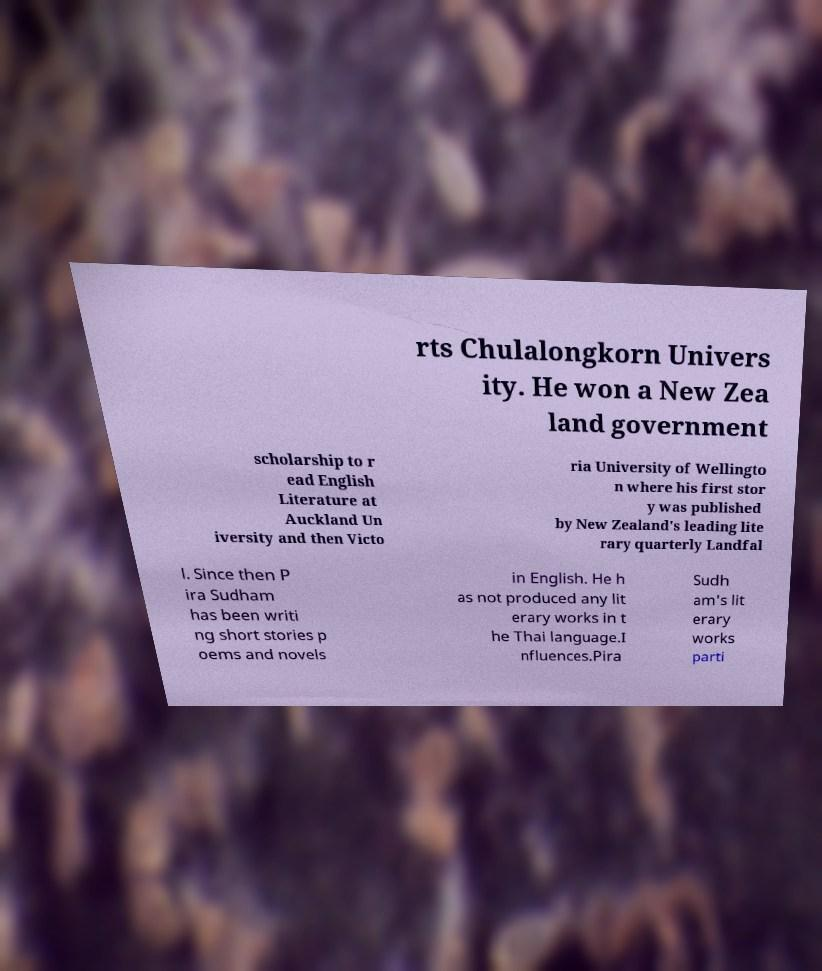Could you assist in decoding the text presented in this image and type it out clearly? rts Chulalongkorn Univers ity. He won a New Zea land government scholarship to r ead English Literature at Auckland Un iversity and then Victo ria University of Wellingto n where his first stor y was published by New Zealand's leading lite rary quarterly Landfal l. Since then P ira Sudham has been writi ng short stories p oems and novels in English. He h as not produced any lit erary works in t he Thai language.I nfluences.Pira Sudh am's lit erary works parti 